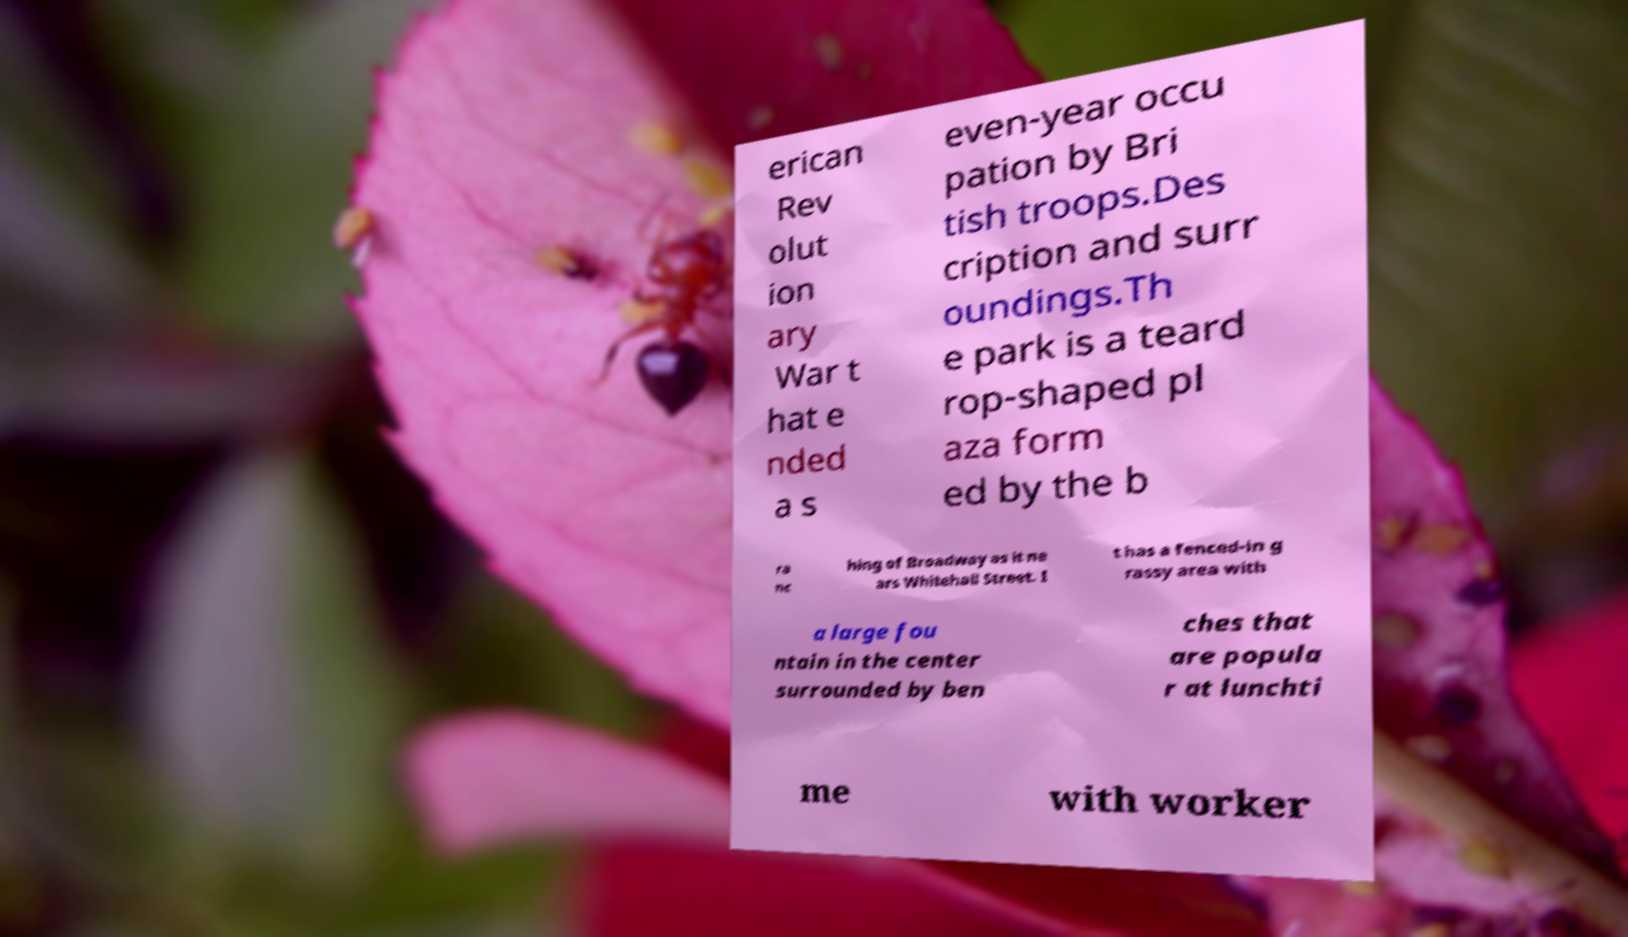For documentation purposes, I need the text within this image transcribed. Could you provide that? erican Rev olut ion ary War t hat e nded a s even-year occu pation by Bri tish troops.Des cription and surr oundings.Th e park is a teard rop-shaped pl aza form ed by the b ra nc hing of Broadway as it ne ars Whitehall Street. I t has a fenced-in g rassy area with a large fou ntain in the center surrounded by ben ches that are popula r at lunchti me with worker 